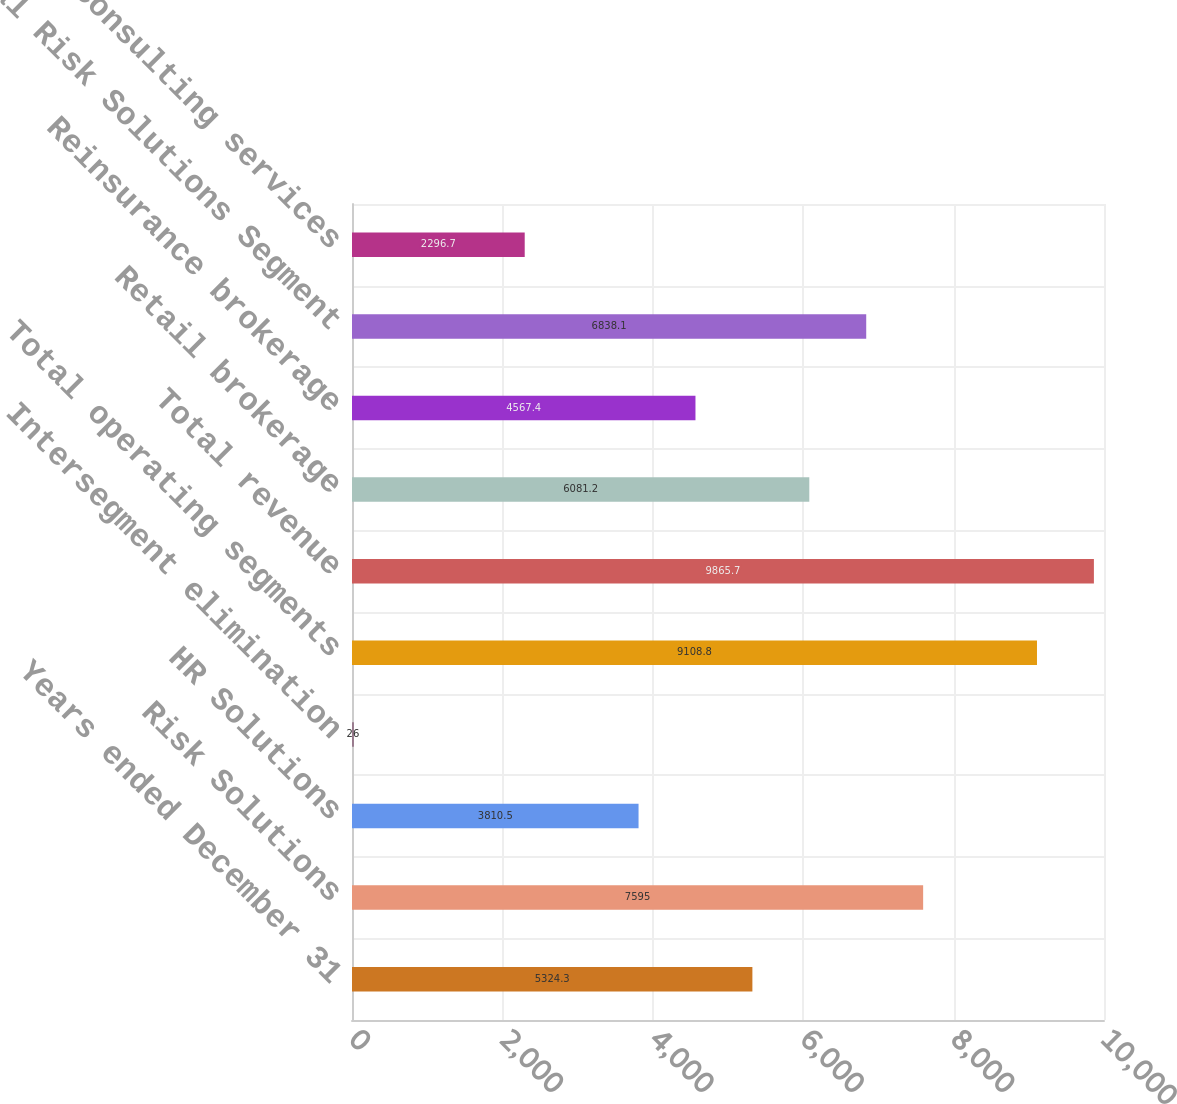Convert chart to OTSL. <chart><loc_0><loc_0><loc_500><loc_500><bar_chart><fcel>Years ended December 31<fcel>Risk Solutions<fcel>HR Solutions<fcel>Intersegment elimination<fcel>Total operating segments<fcel>Total revenue<fcel>Retail brokerage<fcel>Reinsurance brokerage<fcel>Total Risk Solutions Segment<fcel>Consulting services<nl><fcel>5324.3<fcel>7595<fcel>3810.5<fcel>26<fcel>9108.8<fcel>9865.7<fcel>6081.2<fcel>4567.4<fcel>6838.1<fcel>2296.7<nl></chart> 